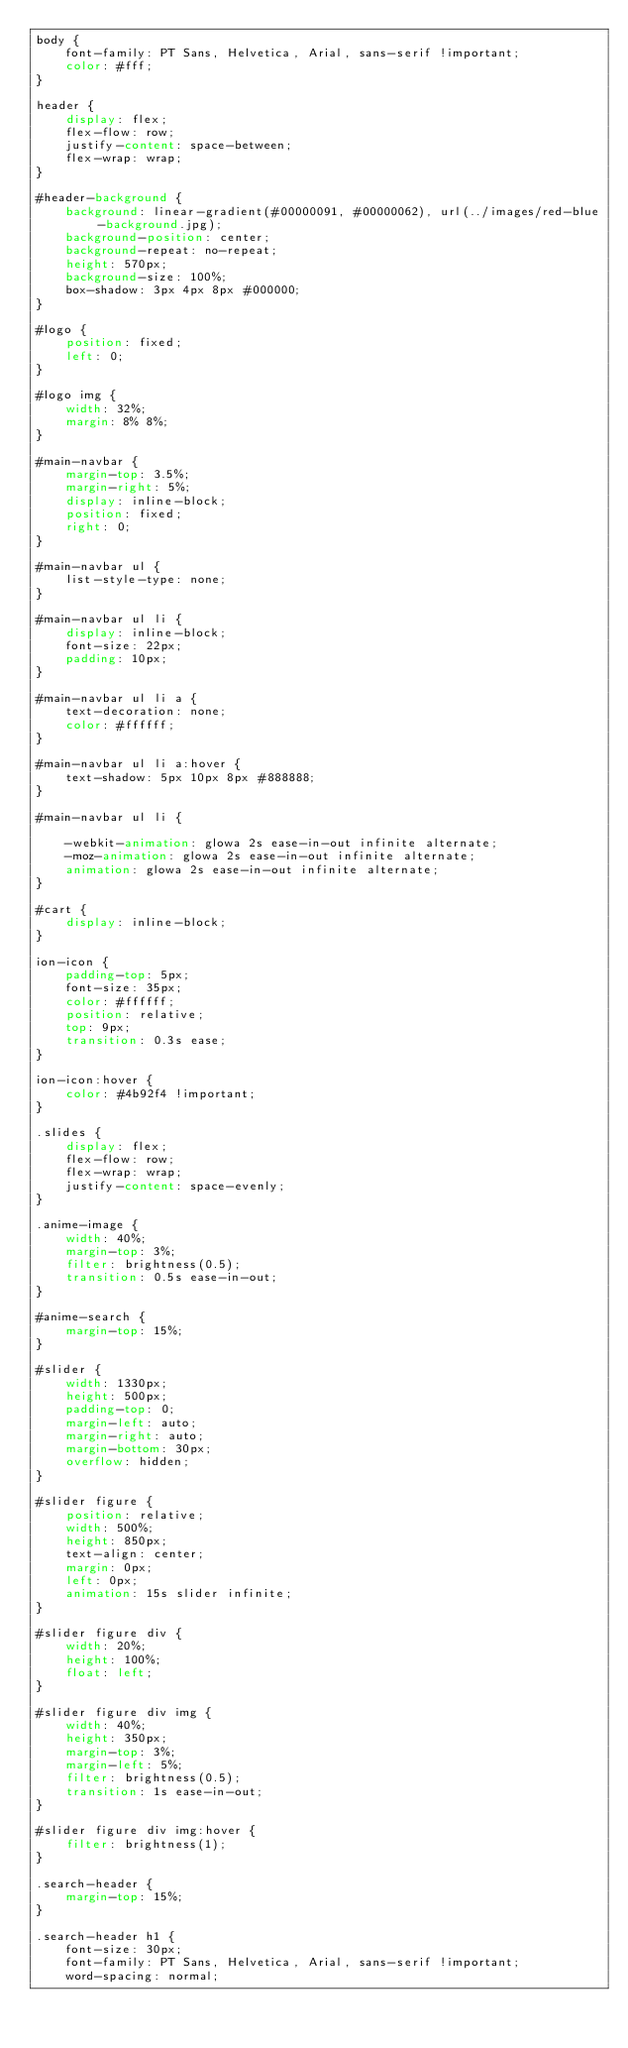<code> <loc_0><loc_0><loc_500><loc_500><_CSS_>body {
    font-family: PT Sans, Helvetica, Arial, sans-serif !important;
    color: #fff;
}

header {
    display: flex;
    flex-flow: row;
    justify-content: space-between;
    flex-wrap: wrap;
}

#header-background {
    background: linear-gradient(#00000091, #00000062), url(../images/red-blue-background.jpg);
    background-position: center;
    background-repeat: no-repeat;
    height: 570px;
    background-size: 100%;
    box-shadow: 3px 4px 8px #000000;
}

#logo {
    position: fixed;
    left: 0;
}

#logo img {
    width: 32%;
    margin: 8% 8%;
}

#main-navbar {
    margin-top: 3.5%;
    margin-right: 5%;
    display: inline-block;
    position: fixed;
    right: 0;
}

#main-navbar ul {
    list-style-type: none;
}

#main-navbar ul li {
    display: inline-block;
    font-size: 22px;
    padding: 10px;
}

#main-navbar ul li a {
    text-decoration: none;
    color: #ffffff;
}

#main-navbar ul li a:hover {
    text-shadow: 5px 10px 8px #888888;
}

#main-navbar ul li {

    -webkit-animation: glowa 2s ease-in-out infinite alternate;
    -moz-animation: glowa 2s ease-in-out infinite alternate;
    animation: glowa 2s ease-in-out infinite alternate;
}

#cart {
    display: inline-block;
}

ion-icon {
    padding-top: 5px;
    font-size: 35px;
    color: #ffffff;
    position: relative;
    top: 9px;
    transition: 0.3s ease;
}

ion-icon:hover {
    color: #4b92f4 !important;
}

.slides {
    display: flex;
    flex-flow: row;
    flex-wrap: wrap;
    justify-content: space-evenly;
}

.anime-image {
    width: 40%;
    margin-top: 3%;
    filter: brightness(0.5);
    transition: 0.5s ease-in-out;
}

#anime-search {
    margin-top: 15%;
}

#slider {
    width: 1330px;
    height: 500px;
    padding-top: 0;
    margin-left: auto;
    margin-right: auto;
    margin-bottom: 30px;
    overflow: hidden;
}

#slider figure {
    position: relative;
    width: 500%;
    height: 850px;
    text-align: center;
    margin: 0px;
    left: 0px;
    animation: 15s slider infinite;
}

#slider figure div {
    width: 20%;
    height: 100%;
    float: left;
}

#slider figure div img {
    width: 40%;
    height: 350px;
    margin-top: 3%;
    margin-left: 5%;
    filter: brightness(0.5);
    transition: 1s ease-in-out;
}

#slider figure div img:hover {
    filter: brightness(1);
}

.search-header {
    margin-top: 15%;
}

.search-header h1 {
    font-size: 30px;
    font-family: PT Sans, Helvetica, Arial, sans-serif !important;
    word-spacing: normal;</code> 